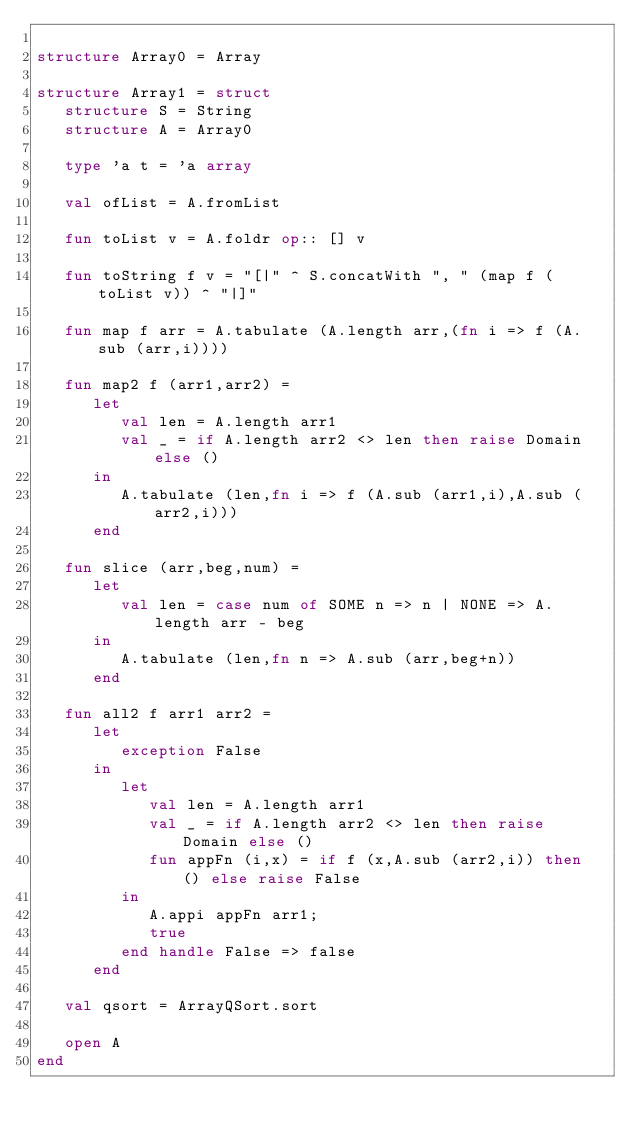Convert code to text. <code><loc_0><loc_0><loc_500><loc_500><_SML_>
structure Array0 = Array

structure Array1 = struct
   structure S = String
   structure A = Array0

   type 'a t = 'a array

   val ofList = A.fromList

   fun toList v = A.foldr op:: [] v

   fun toString f v = "[|" ^ S.concatWith ", " (map f (toList v)) ^ "|]"

   fun map f arr = A.tabulate (A.length arr,(fn i => f (A.sub (arr,i))))

   fun map2 f (arr1,arr2) =
      let
         val len = A.length arr1
         val _ = if A.length arr2 <> len then raise Domain else ()
      in
         A.tabulate (len,fn i => f (A.sub (arr1,i),A.sub (arr2,i)))
      end

   fun slice (arr,beg,num) =
      let
         val len = case num of SOME n => n | NONE => A.length arr - beg
      in
         A.tabulate (len,fn n => A.sub (arr,beg+n))
      end

   fun all2 f arr1 arr2 =
      let
         exception False
      in
         let
            val len = A.length arr1
            val _ = if A.length arr2 <> len then raise Domain else ()
            fun appFn (i,x) = if f (x,A.sub (arr2,i)) then () else raise False
         in
            A.appi appFn arr1;
            true
         end handle False => false
      end

   val qsort = ArrayQSort.sort

   open A
end
</code> 